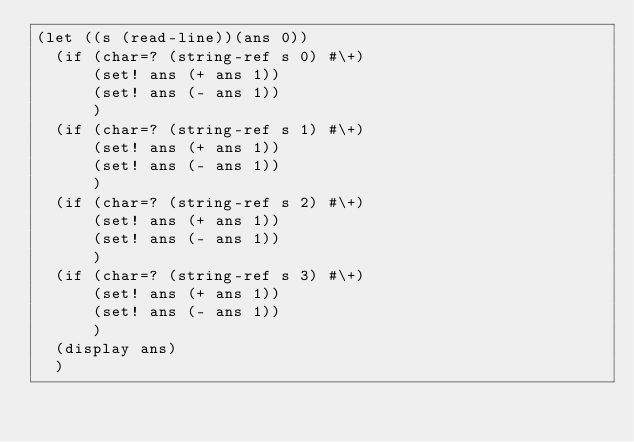<code> <loc_0><loc_0><loc_500><loc_500><_Scheme_>(let ((s (read-line))(ans 0))
  (if (char=? (string-ref s 0) #\+)
      (set! ans (+ ans 1))
      (set! ans (- ans 1))
      )
  (if (char=? (string-ref s 1) #\+)
      (set! ans (+ ans 1))
      (set! ans (- ans 1))
      )
  (if (char=? (string-ref s 2) #\+)
      (set! ans (+ ans 1))
      (set! ans (- ans 1))
      )
  (if (char=? (string-ref s 3) #\+)
      (set! ans (+ ans 1))
      (set! ans (- ans 1))
      )
  (display ans)
  )


</code> 